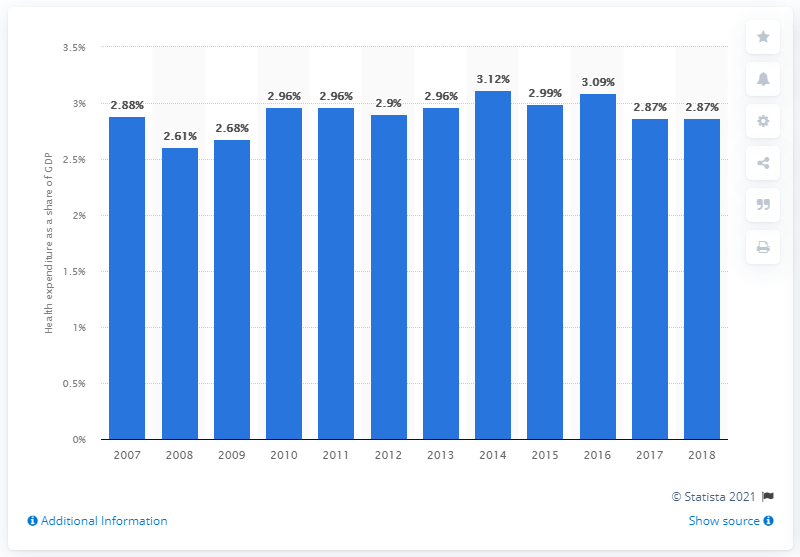Draw attention to some important aspects in this diagram. In 2018, approximately 2.9% of Indonesia's Gross Domestic Product (GDP) was allocated towards health services. According to the data, approximately 2.61% of Indonesia's Gross Domestic Product (GDP) is allocated towards health services. 